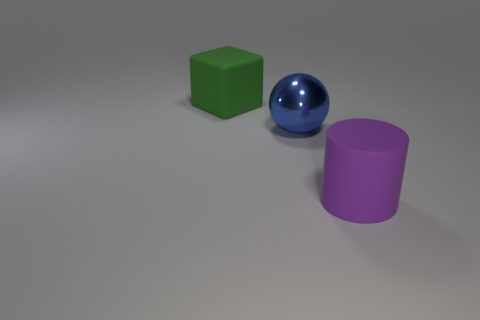Add 3 big green things. How many objects exist? 6 Subtract all balls. How many objects are left? 2 Subtract 0 red blocks. How many objects are left? 3 Subtract all large shiny blocks. Subtract all matte blocks. How many objects are left? 2 Add 2 large things. How many large things are left? 5 Add 1 matte blocks. How many matte blocks exist? 2 